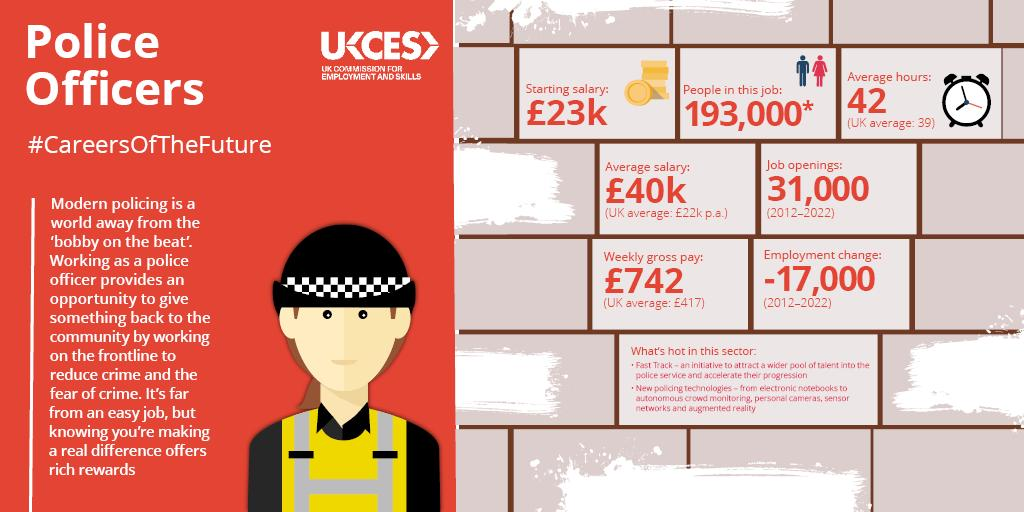Outline some significant characteristics in this image. As of 2011-2022, there were approximately 31,000 job openings in the police service in the UK. According to recent data, approximately 193,000 individuals are employed as police officers in the United Kingdom. In the United Kingdom, police officers typically earn a starting salary of approximately £23,000 per year. 